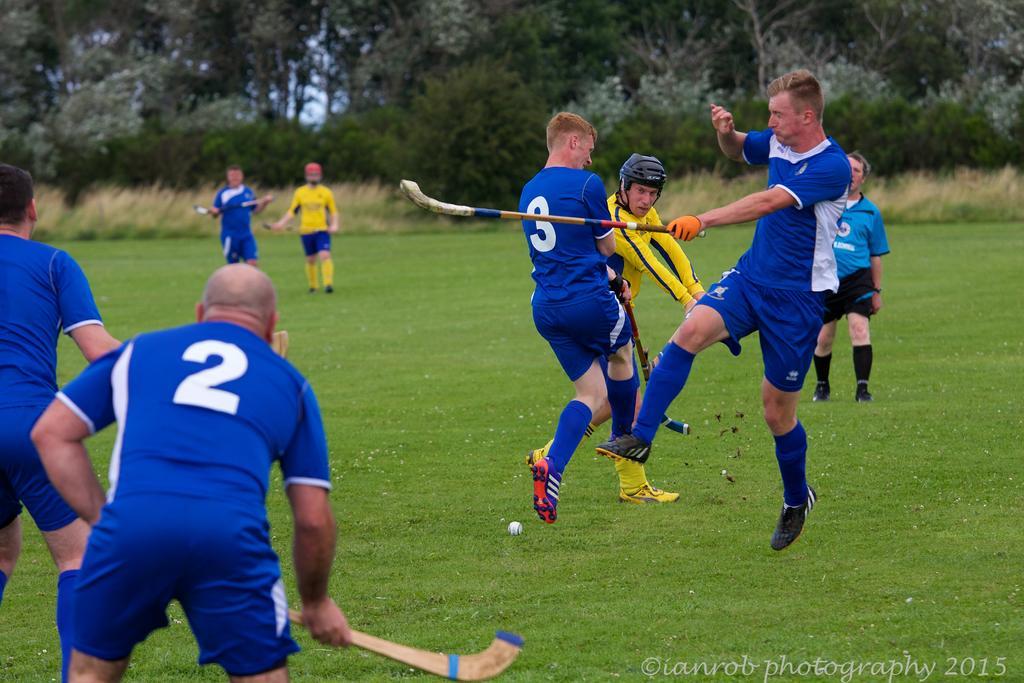Please provide a concise description of this image. There is a group of persons are playing hockey in a grassy land as we can see at the bottom of this image. There are some trees in the background. There is a watermark at the bottom right corner of this image. 